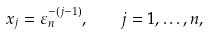<formula> <loc_0><loc_0><loc_500><loc_500>x _ { j } = \varepsilon _ { n } ^ { - ( j - 1 ) } , \quad j = 1 , \dots , n ,</formula> 